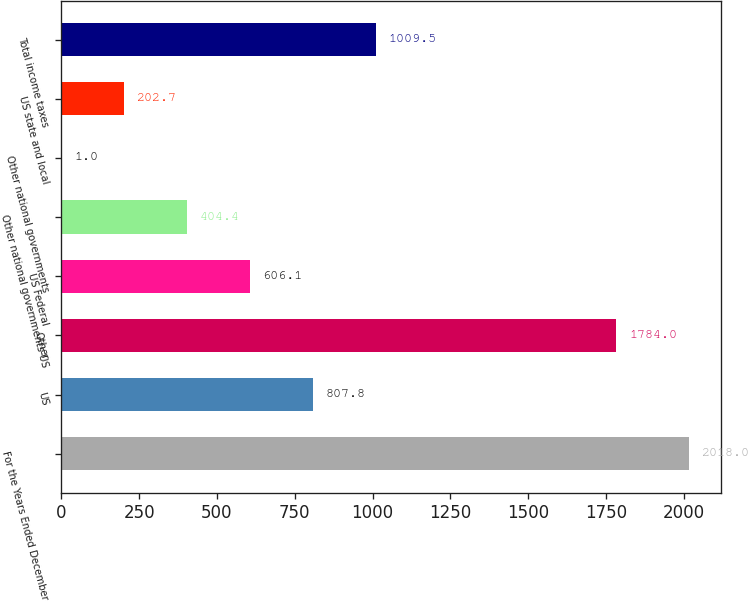Convert chart. <chart><loc_0><loc_0><loc_500><loc_500><bar_chart><fcel>For the Years Ended December<fcel>US<fcel>Other<fcel>US Federal<fcel>Other national governments US<fcel>Other national governments<fcel>US state and local<fcel>Total income taxes<nl><fcel>2018<fcel>807.8<fcel>1784<fcel>606.1<fcel>404.4<fcel>1<fcel>202.7<fcel>1009.5<nl></chart> 